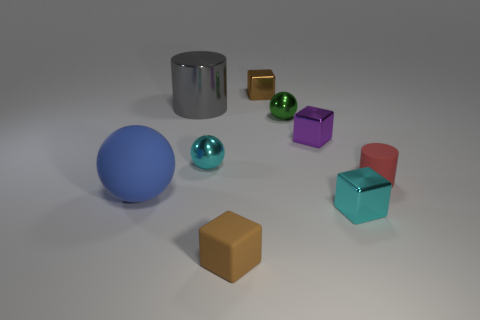Subtract all red cylinders. How many cylinders are left? 1 Subtract all metallic cubes. How many cubes are left? 1 Subtract all cylinders. How many objects are left? 7 Subtract 1 balls. How many balls are left? 2 Subtract all blue cubes. How many brown cylinders are left? 0 Subtract all metal cubes. Subtract all small rubber blocks. How many objects are left? 5 Add 3 big gray objects. How many big gray objects are left? 4 Add 2 small red metallic cubes. How many small red metallic cubes exist? 2 Subtract 0 green blocks. How many objects are left? 9 Subtract all red balls. Subtract all cyan blocks. How many balls are left? 3 